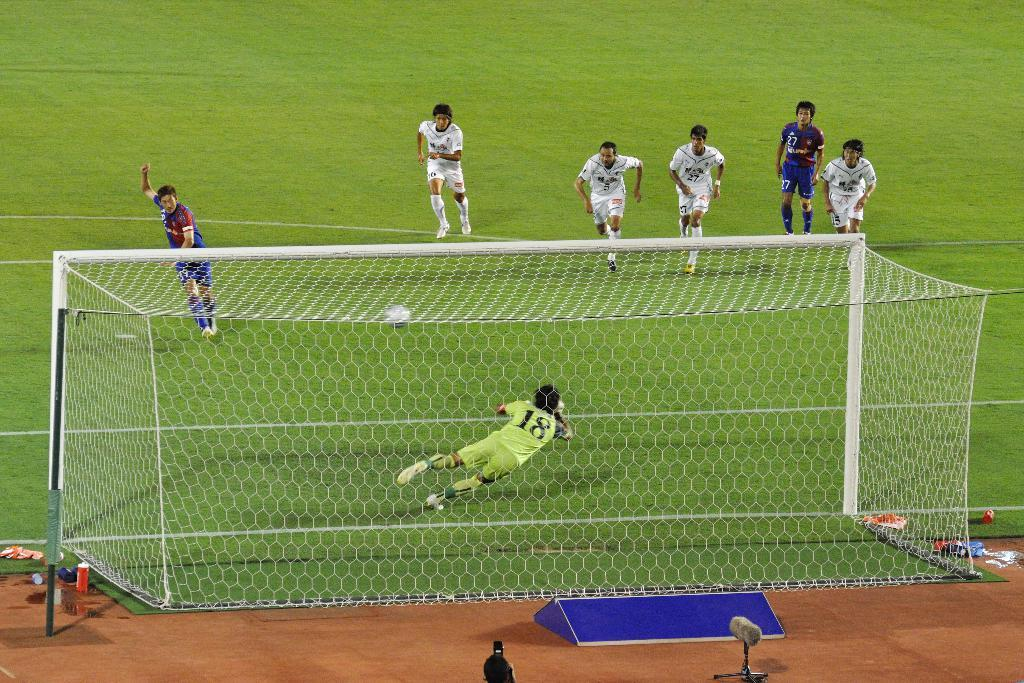<image>
Give a short and clear explanation of the subsequent image. The goalkeeper number eighteen is mid air as he tries to stop the penalty. 